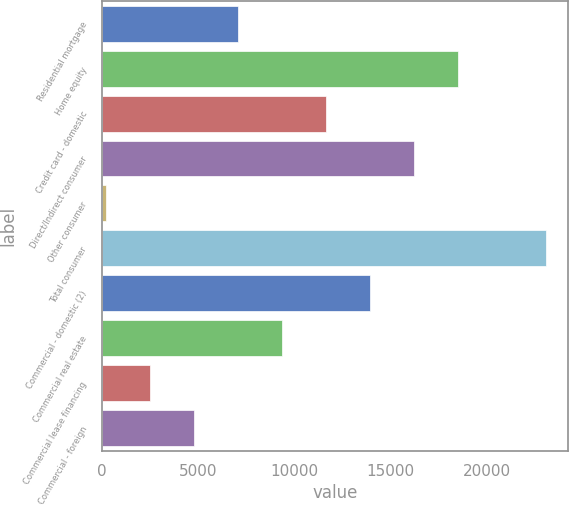Convert chart. <chart><loc_0><loc_0><loc_500><loc_500><bar_chart><fcel>Residential mortgage<fcel>Home equity<fcel>Credit card - domestic<fcel>Direct/Indirect consumer<fcel>Other consumer<fcel>Total consumer<fcel>Commercial - domestic (2)<fcel>Commercial real estate<fcel>Commercial lease financing<fcel>Commercial - foreign<nl><fcel>7063.4<fcel>18497.4<fcel>11637<fcel>16210.6<fcel>203<fcel>23071<fcel>13923.8<fcel>9350.2<fcel>2489.8<fcel>4776.6<nl></chart> 